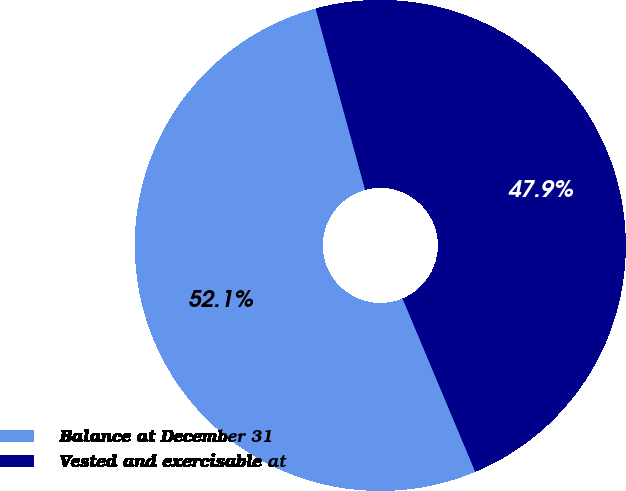<chart> <loc_0><loc_0><loc_500><loc_500><pie_chart><fcel>Balance at December 31<fcel>Vested and exercisable at<nl><fcel>52.08%<fcel>47.92%<nl></chart> 